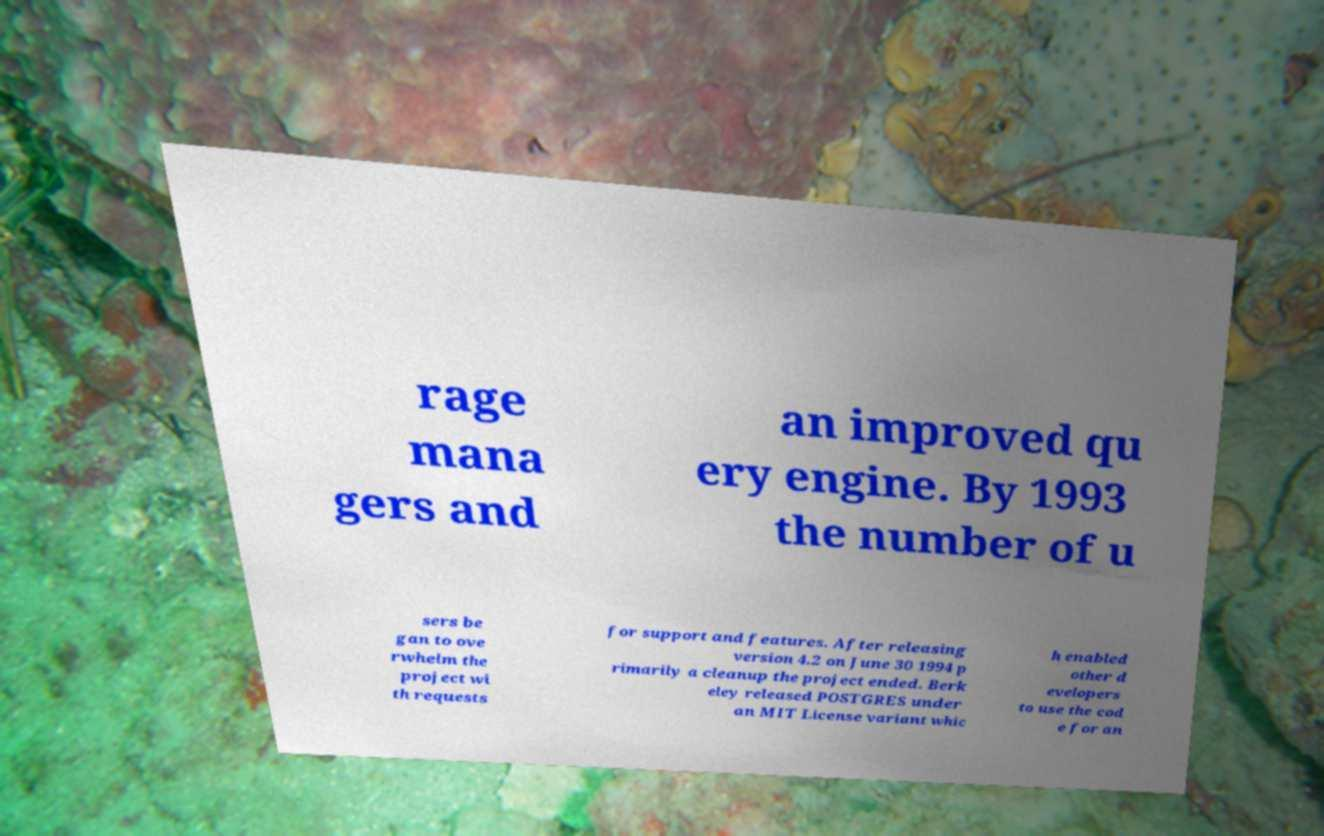What messages or text are displayed in this image? I need them in a readable, typed format. rage mana gers and an improved qu ery engine. By 1993 the number of u sers be gan to ove rwhelm the project wi th requests for support and features. After releasing version 4.2 on June 30 1994 p rimarily a cleanup the project ended. Berk eley released POSTGRES under an MIT License variant whic h enabled other d evelopers to use the cod e for an 